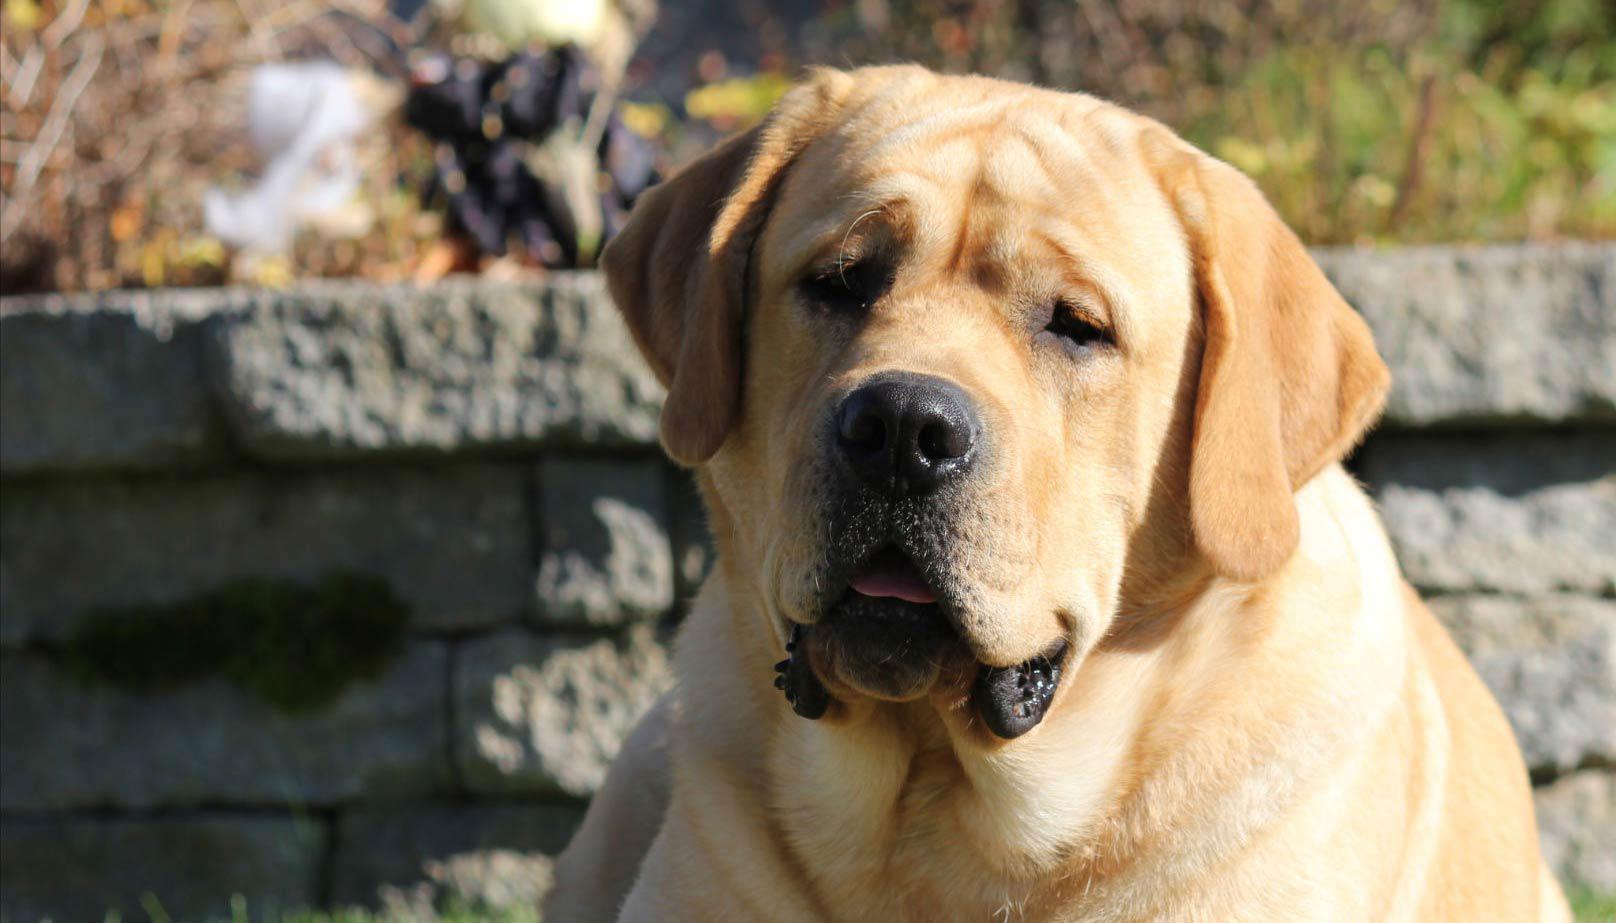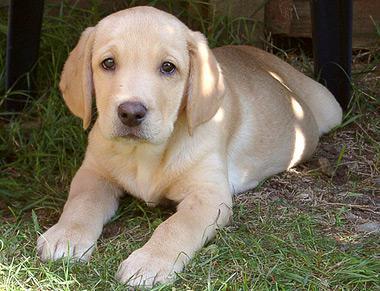The first image is the image on the left, the second image is the image on the right. Assess this claim about the two images: "An image shows a standing dog with an open mouth and a collar around its neck.". Correct or not? Answer yes or no. No. The first image is the image on the left, the second image is the image on the right. Considering the images on both sides, is "One of the dogs is lying down and looking at the camera." valid? Answer yes or no. Yes. 